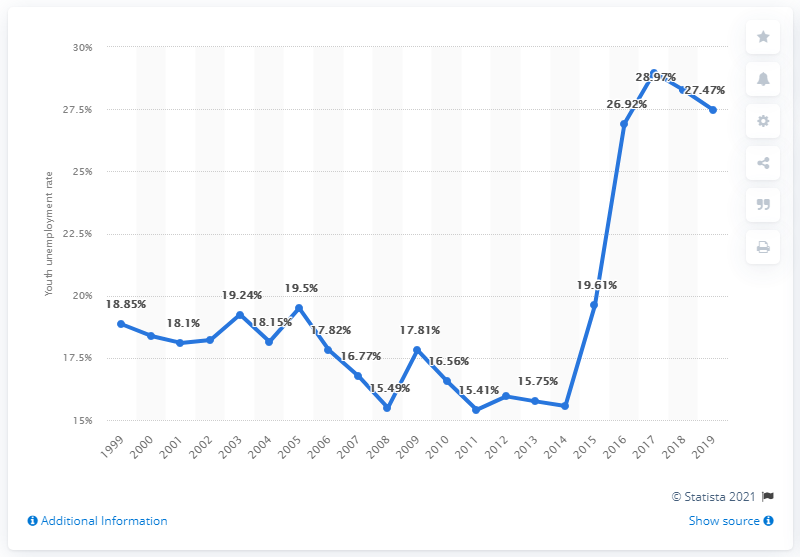Specify some key components in this picture. In 2019, the youth unemployment rate in Brazil was 27.47%. 